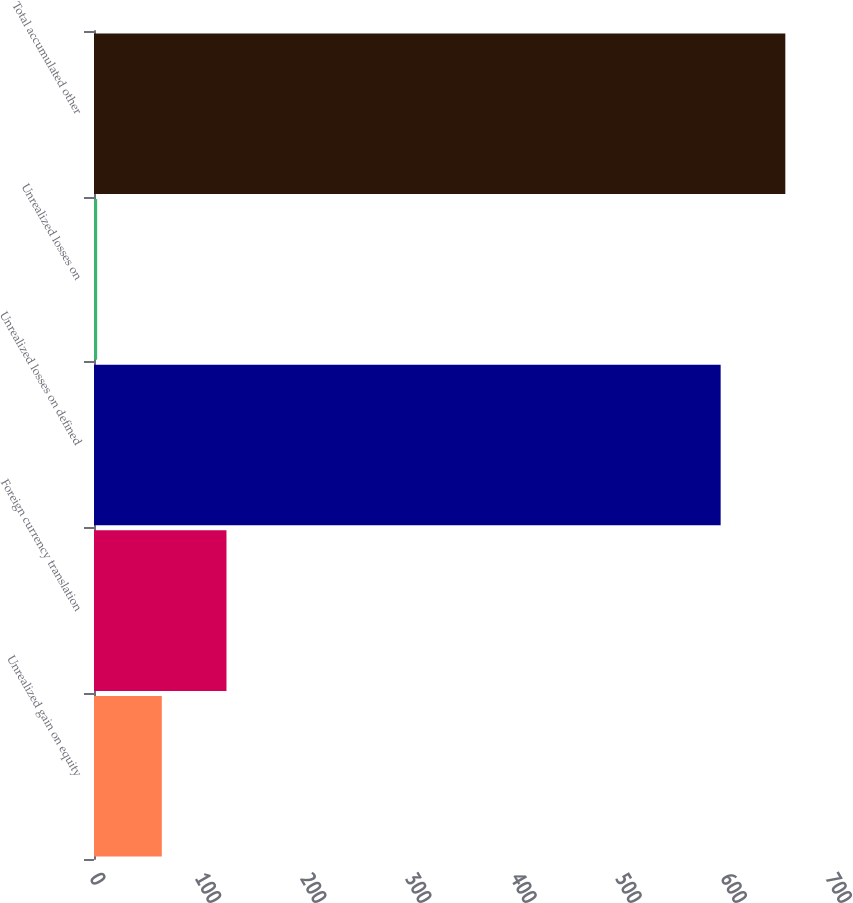Convert chart to OTSL. <chart><loc_0><loc_0><loc_500><loc_500><bar_chart><fcel>Unrealized gain on equity<fcel>Foreign currency translation<fcel>Unrealized losses on defined<fcel>Unrealized losses on<fcel>Total accumulated other<nl><fcel>64.5<fcel>126<fcel>596<fcel>3<fcel>657.5<nl></chart> 